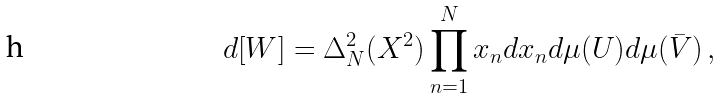<formula> <loc_0><loc_0><loc_500><loc_500>d [ W ] = \Delta _ { N } ^ { 2 } ( X ^ { 2 } ) \prod _ { n = 1 } ^ { N } x _ { n } d x _ { n } d \mu ( U ) d \mu ( \bar { V } ) \, ,</formula> 